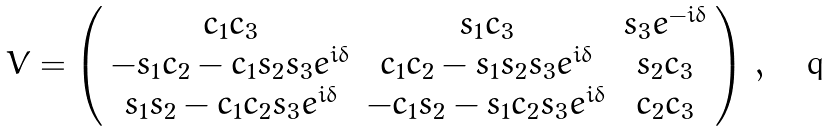<formula> <loc_0><loc_0><loc_500><loc_500>V = \left ( \begin{array} { c c c } c _ { 1 } c _ { 3 } & s _ { 1 } c _ { 3 } & s _ { 3 } e ^ { - i \delta } \\ - s _ { 1 } c _ { 2 } - c _ { 1 } s _ { 2 } s _ { 3 } e ^ { i \delta } & c _ { 1 } c _ { 2 } - s _ { 1 } s _ { 2 } s _ { 3 } e ^ { i \delta } & s _ { 2 } c _ { 3 } \\ s _ { 1 } s _ { 2 } - c _ { 1 } c _ { 2 } s _ { 3 } e ^ { i \delta } & - c _ { 1 } s _ { 2 } - s _ { 1 } c _ { 2 } s _ { 3 } e ^ { i \delta } & c _ { 2 } c _ { 3 } \end{array} \right ) \, ,</formula> 